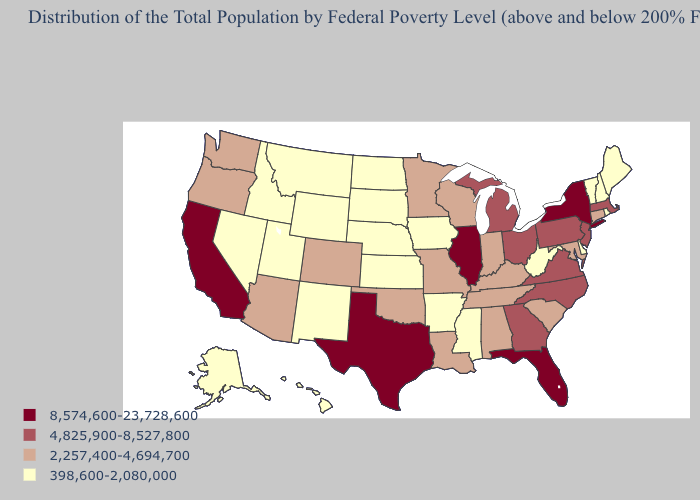Which states have the lowest value in the South?
Be succinct. Arkansas, Delaware, Mississippi, West Virginia. Does Hawaii have the highest value in the USA?
Write a very short answer. No. Does the map have missing data?
Keep it brief. No. What is the value of Rhode Island?
Short answer required. 398,600-2,080,000. What is the lowest value in the USA?
Give a very brief answer. 398,600-2,080,000. Does Florida have the highest value in the South?
Quick response, please. Yes. What is the value of Oregon?
Answer briefly. 2,257,400-4,694,700. Does Kentucky have the lowest value in the South?
Write a very short answer. No. What is the highest value in the USA?
Keep it brief. 8,574,600-23,728,600. Name the states that have a value in the range 2,257,400-4,694,700?
Short answer required. Alabama, Arizona, Colorado, Connecticut, Indiana, Kentucky, Louisiana, Maryland, Minnesota, Missouri, Oklahoma, Oregon, South Carolina, Tennessee, Washington, Wisconsin. What is the value of Minnesota?
Concise answer only. 2,257,400-4,694,700. Does Massachusetts have a lower value than New York?
Keep it brief. Yes. What is the value of Michigan?
Quick response, please. 4,825,900-8,527,800. Which states have the lowest value in the USA?
Short answer required. Alaska, Arkansas, Delaware, Hawaii, Idaho, Iowa, Kansas, Maine, Mississippi, Montana, Nebraska, Nevada, New Hampshire, New Mexico, North Dakota, Rhode Island, South Dakota, Utah, Vermont, West Virginia, Wyoming. What is the value of Florida?
Be succinct. 8,574,600-23,728,600. 